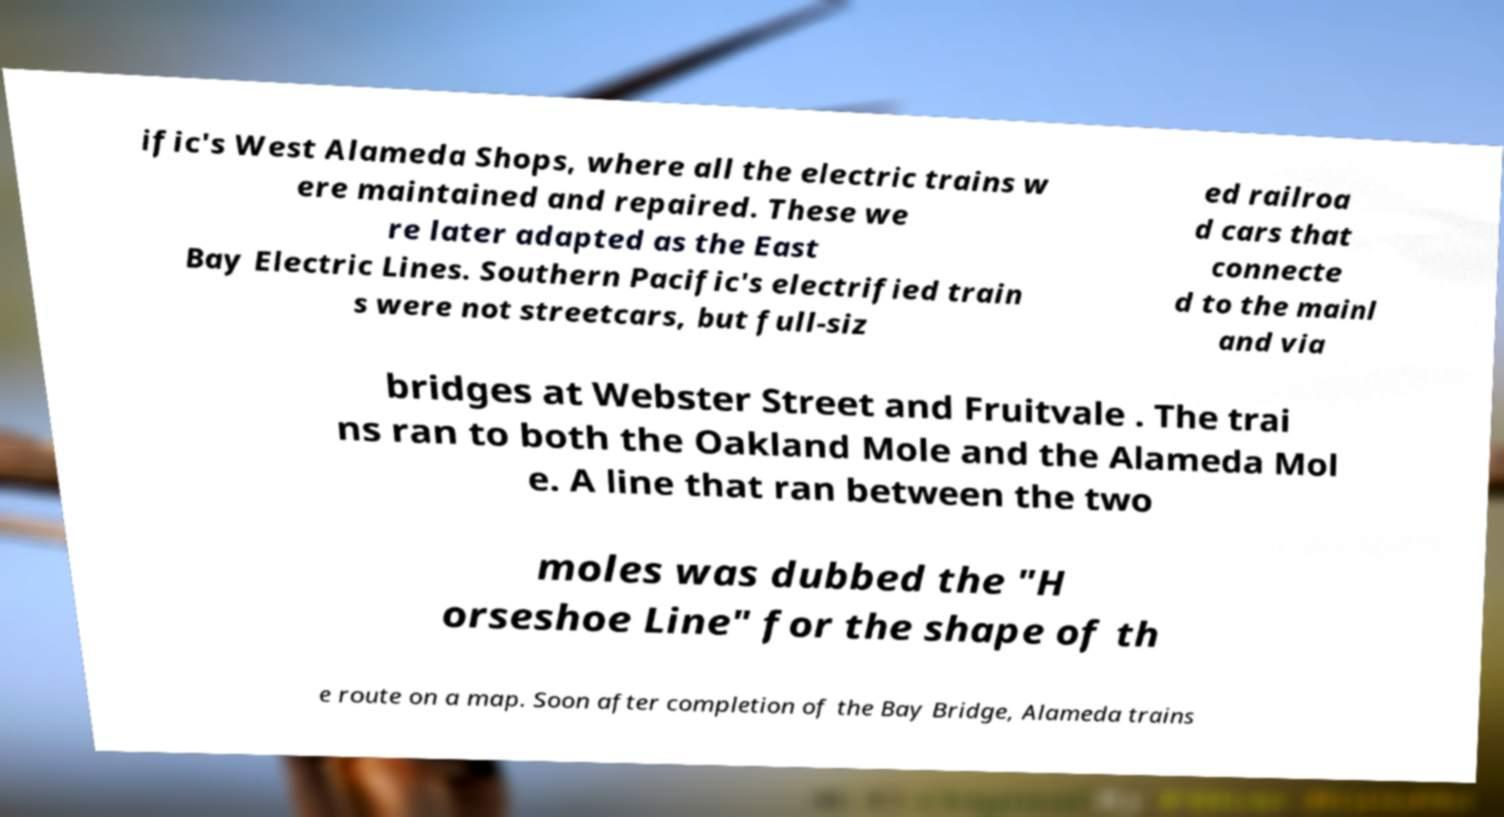Please read and relay the text visible in this image. What does it say? ific's West Alameda Shops, where all the electric trains w ere maintained and repaired. These we re later adapted as the East Bay Electric Lines. Southern Pacific's electrified train s were not streetcars, but full-siz ed railroa d cars that connecte d to the mainl and via bridges at Webster Street and Fruitvale . The trai ns ran to both the Oakland Mole and the Alameda Mol e. A line that ran between the two moles was dubbed the "H orseshoe Line" for the shape of th e route on a map. Soon after completion of the Bay Bridge, Alameda trains 